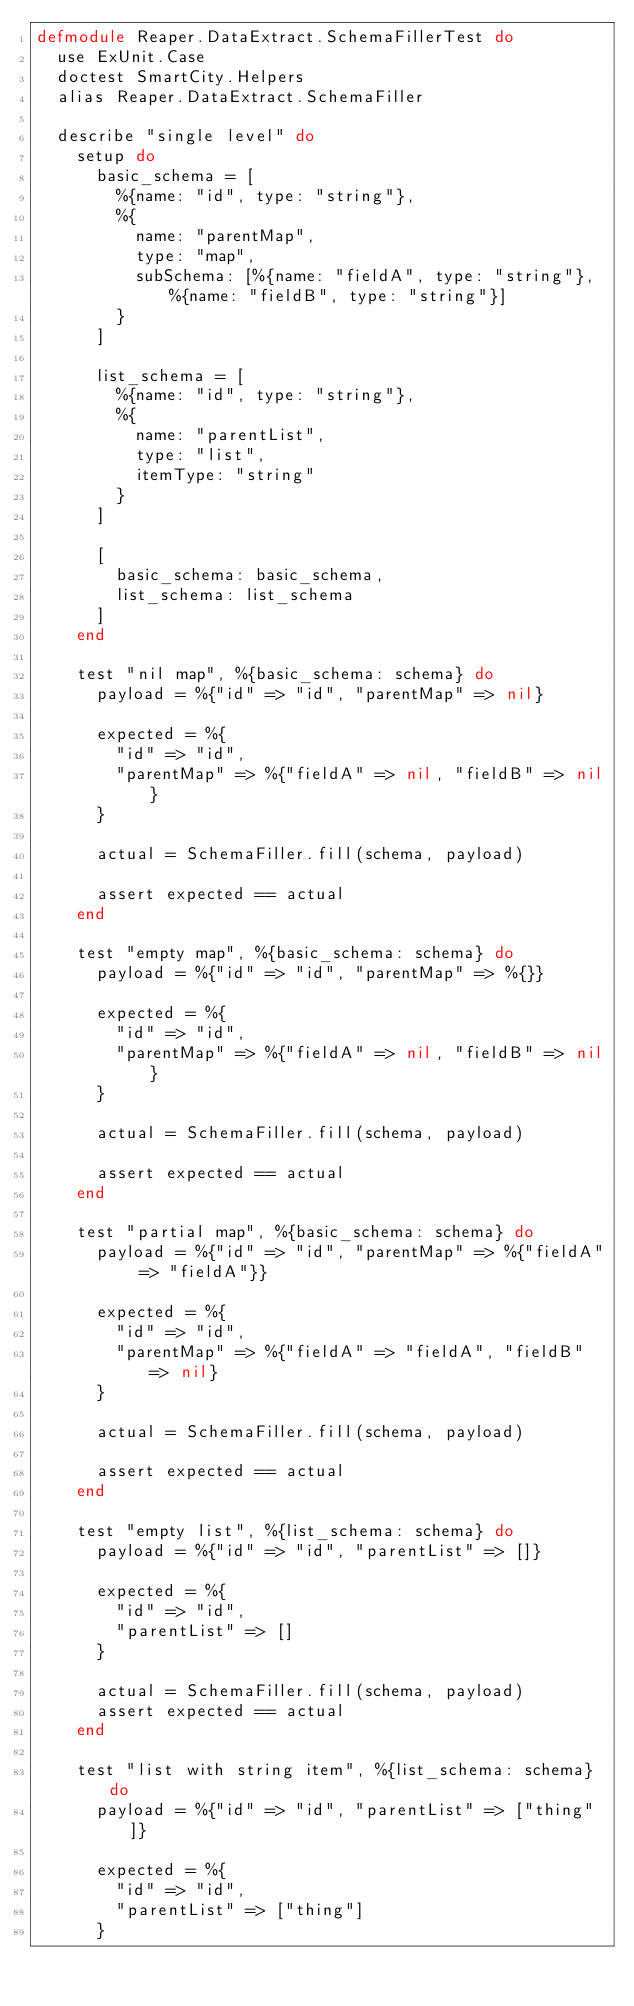Convert code to text. <code><loc_0><loc_0><loc_500><loc_500><_Elixir_>defmodule Reaper.DataExtract.SchemaFillerTest do
  use ExUnit.Case
  doctest SmartCity.Helpers
  alias Reaper.DataExtract.SchemaFiller

  describe "single level" do
    setup do
      basic_schema = [
        %{name: "id", type: "string"},
        %{
          name: "parentMap",
          type: "map",
          subSchema: [%{name: "fieldA", type: "string"}, %{name: "fieldB", type: "string"}]
        }
      ]

      list_schema = [
        %{name: "id", type: "string"},
        %{
          name: "parentList",
          type: "list",
          itemType: "string"
        }
      ]

      [
        basic_schema: basic_schema,
        list_schema: list_schema
      ]
    end

    test "nil map", %{basic_schema: schema} do
      payload = %{"id" => "id", "parentMap" => nil}

      expected = %{
        "id" => "id",
        "parentMap" => %{"fieldA" => nil, "fieldB" => nil}
      }

      actual = SchemaFiller.fill(schema, payload)

      assert expected == actual
    end

    test "empty map", %{basic_schema: schema} do
      payload = %{"id" => "id", "parentMap" => %{}}

      expected = %{
        "id" => "id",
        "parentMap" => %{"fieldA" => nil, "fieldB" => nil}
      }

      actual = SchemaFiller.fill(schema, payload)

      assert expected == actual
    end

    test "partial map", %{basic_schema: schema} do
      payload = %{"id" => "id", "parentMap" => %{"fieldA" => "fieldA"}}

      expected = %{
        "id" => "id",
        "parentMap" => %{"fieldA" => "fieldA", "fieldB" => nil}
      }

      actual = SchemaFiller.fill(schema, payload)

      assert expected == actual
    end

    test "empty list", %{list_schema: schema} do
      payload = %{"id" => "id", "parentList" => []}

      expected = %{
        "id" => "id",
        "parentList" => []
      }

      actual = SchemaFiller.fill(schema, payload)
      assert expected == actual
    end

    test "list with string item", %{list_schema: schema} do
      payload = %{"id" => "id", "parentList" => ["thing"]}

      expected = %{
        "id" => "id",
        "parentList" => ["thing"]
      }
</code> 